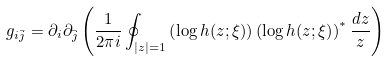Convert formula to latex. <formula><loc_0><loc_0><loc_500><loc_500>g _ { i \bar { j } } = \partial _ { i } \partial _ { \bar { j } } \left ( \frac { 1 } { 2 \pi i } \oint _ { | z | = 1 } \left ( \log { h ( z ; \xi ) } \right ) \left ( \log { h ( z ; \xi ) } \right ) ^ { * } \frac { d z } { z } \right )</formula> 